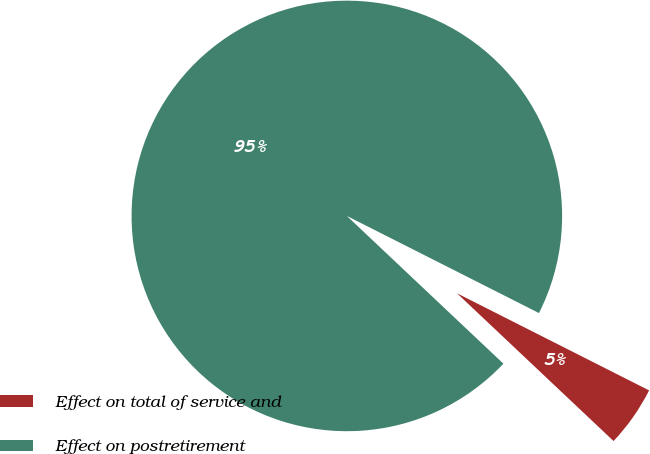<chart> <loc_0><loc_0><loc_500><loc_500><pie_chart><fcel>Effect on total of service and<fcel>Effect on postretirement<nl><fcel>4.59%<fcel>95.41%<nl></chart> 